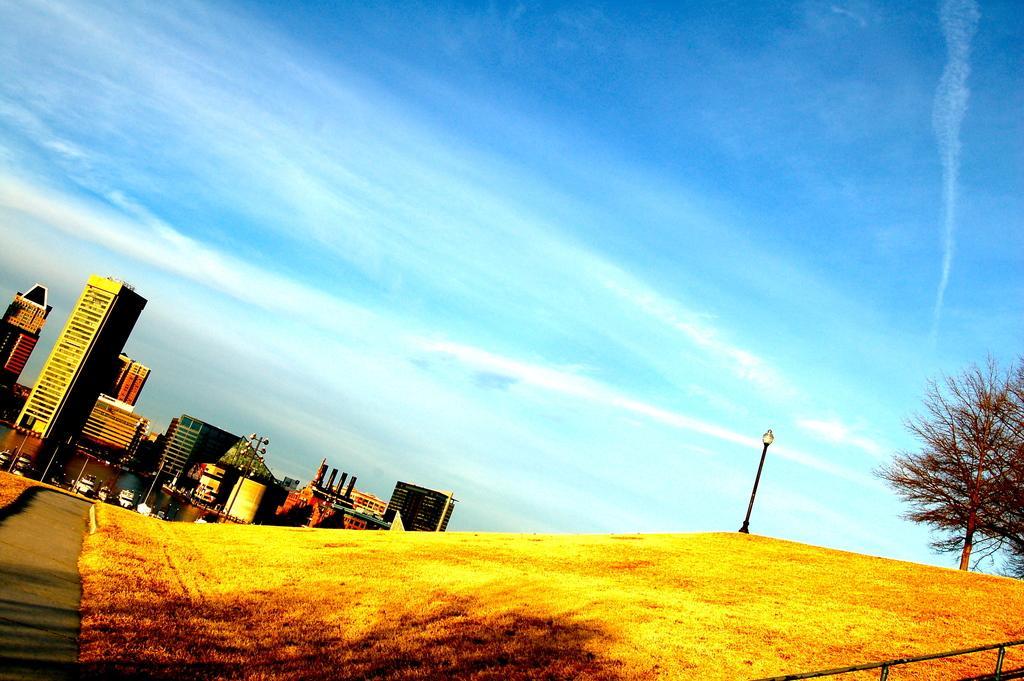Please provide a concise description of this image. In this picture we can see buildings,poles,trees and we can see sky in the background. 